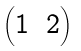Convert formula to latex. <formula><loc_0><loc_0><loc_500><loc_500>\begin{pmatrix} { 1 } & { 2 } \end{pmatrix}</formula> 